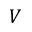<formula> <loc_0><loc_0><loc_500><loc_500>V</formula> 